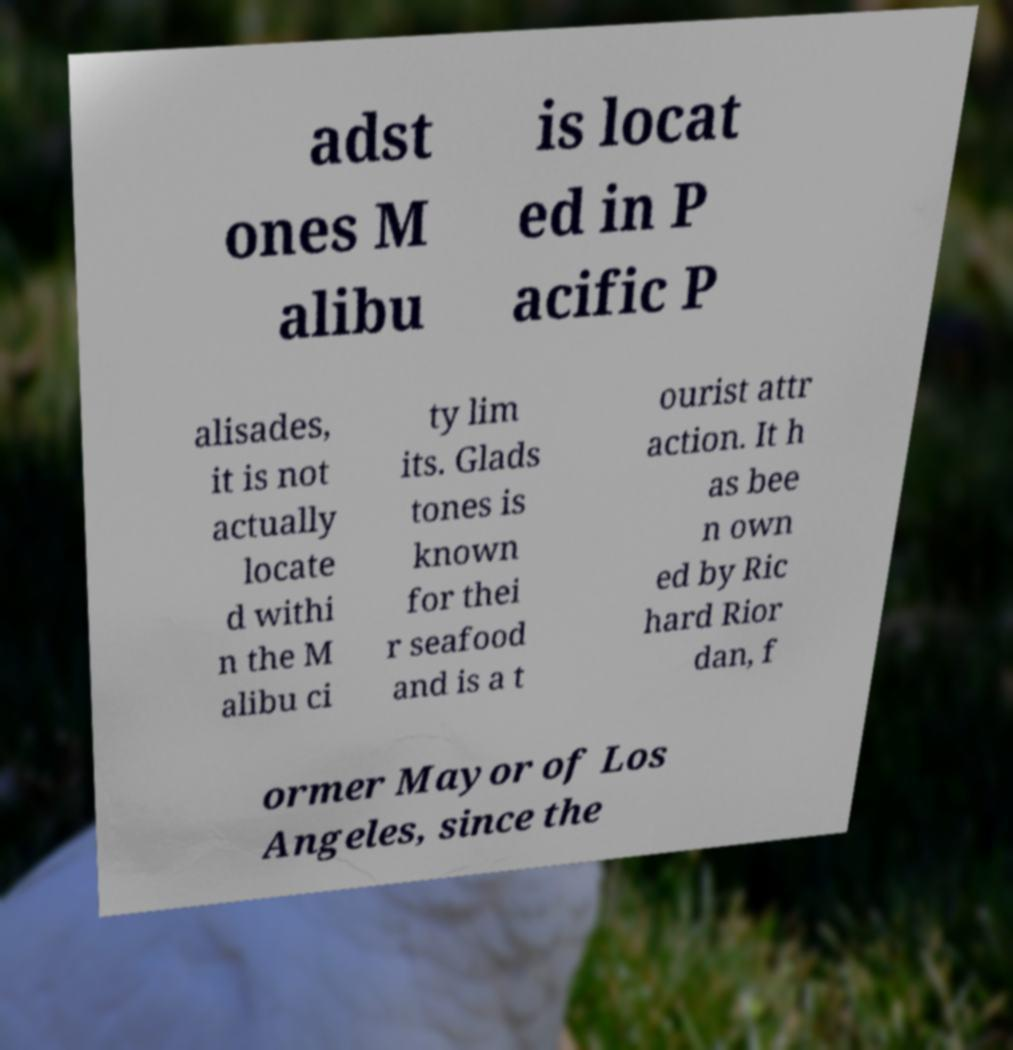What messages or text are displayed in this image? I need them in a readable, typed format. adst ones M alibu is locat ed in P acific P alisades, it is not actually locate d withi n the M alibu ci ty lim its. Glads tones is known for thei r seafood and is a t ourist attr action. It h as bee n own ed by Ric hard Rior dan, f ormer Mayor of Los Angeles, since the 